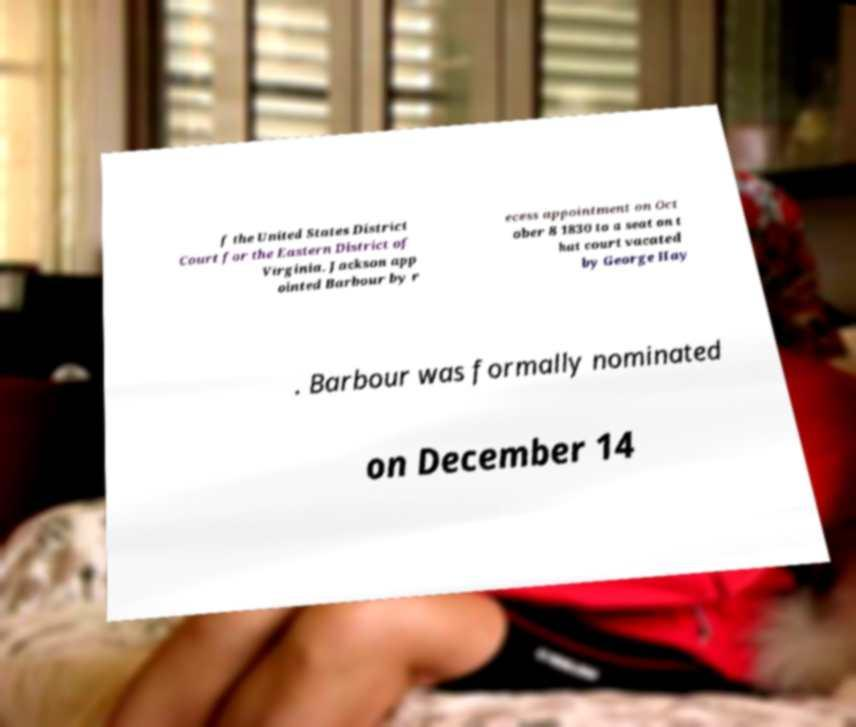What messages or text are displayed in this image? I need them in a readable, typed format. f the United States District Court for the Eastern District of Virginia. Jackson app ointed Barbour by r ecess appointment on Oct ober 8 1830 to a seat on t hat court vacated by George Hay . Barbour was formally nominated on December 14 